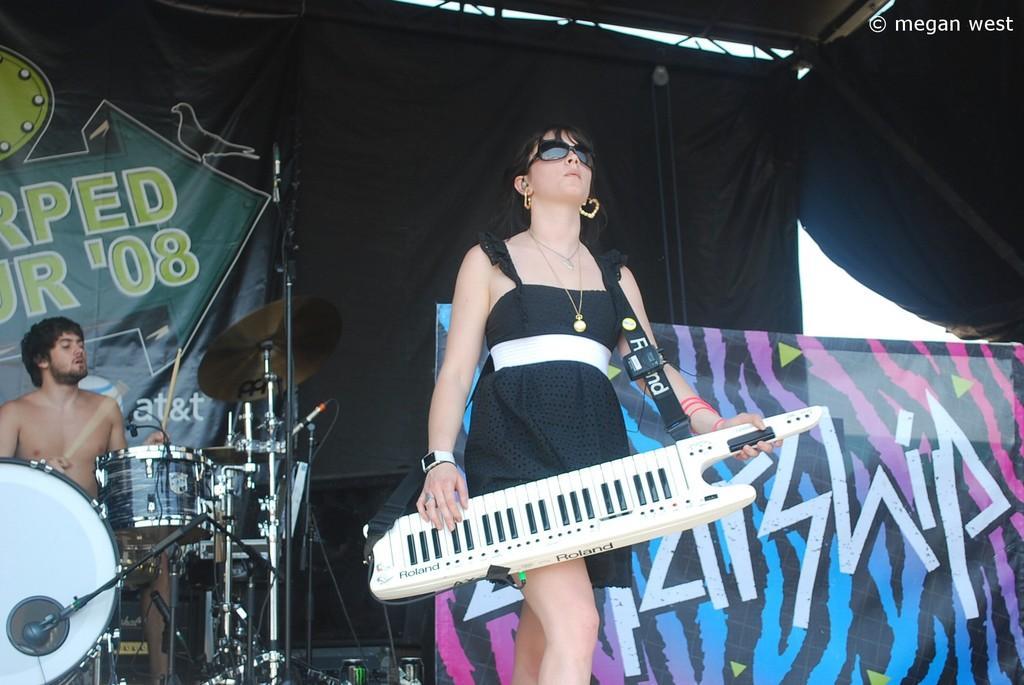In one or two sentences, can you explain what this image depicts? In this image I can see a woman wearing black and white dress is holding a musical instrument in her hand. In the background I can see a person sitting in front of musical instruments, a banner, a tent which is black in color and the sky. 